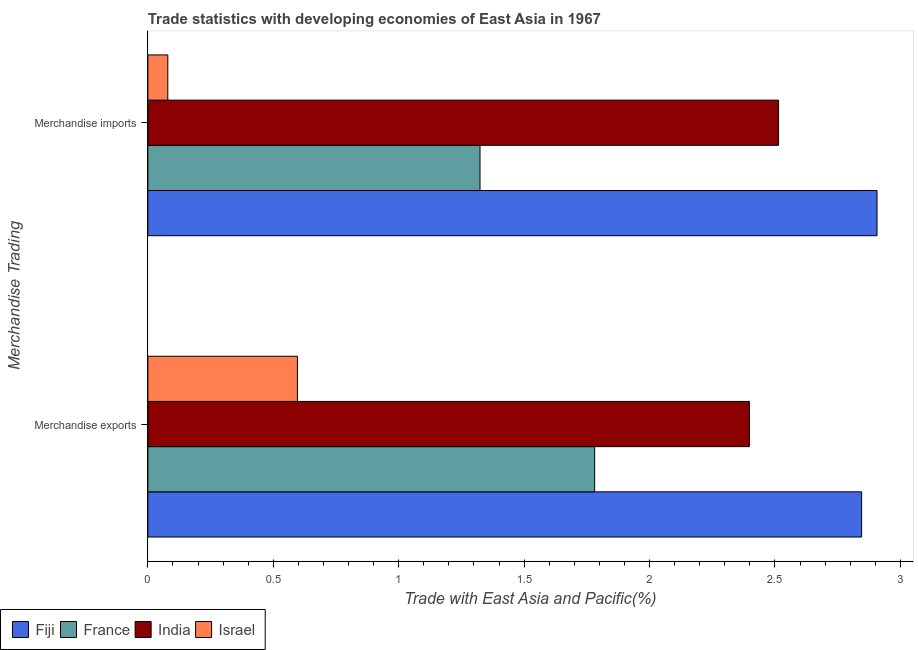How many groups of bars are there?
Make the answer very short. 2. Are the number of bars per tick equal to the number of legend labels?
Your response must be concise. Yes. Are the number of bars on each tick of the Y-axis equal?
Provide a short and direct response. Yes. How many bars are there on the 1st tick from the top?
Offer a terse response. 4. What is the label of the 2nd group of bars from the top?
Offer a very short reply. Merchandise exports. What is the merchandise exports in Israel?
Your answer should be compact. 0.6. Across all countries, what is the maximum merchandise imports?
Your response must be concise. 2.91. Across all countries, what is the minimum merchandise imports?
Your answer should be very brief. 0.08. In which country was the merchandise exports maximum?
Provide a short and direct response. Fiji. What is the total merchandise exports in the graph?
Keep it short and to the point. 7.62. What is the difference between the merchandise imports in France and that in Israel?
Offer a very short reply. 1.24. What is the difference between the merchandise exports in India and the merchandise imports in France?
Provide a short and direct response. 1.07. What is the average merchandise imports per country?
Your answer should be compact. 1.71. What is the difference between the merchandise imports and merchandise exports in India?
Your response must be concise. 0.12. In how many countries, is the merchandise imports greater than 0.4 %?
Give a very brief answer. 3. What is the ratio of the merchandise imports in Israel to that in France?
Make the answer very short. 0.06. In how many countries, is the merchandise exports greater than the average merchandise exports taken over all countries?
Ensure brevity in your answer.  2. What does the 2nd bar from the top in Merchandise imports represents?
Make the answer very short. India. What does the 2nd bar from the bottom in Merchandise exports represents?
Keep it short and to the point. France. How many bars are there?
Make the answer very short. 8. Are all the bars in the graph horizontal?
Provide a succinct answer. Yes. Does the graph contain any zero values?
Offer a terse response. No. Where does the legend appear in the graph?
Keep it short and to the point. Bottom left. How are the legend labels stacked?
Offer a terse response. Horizontal. What is the title of the graph?
Ensure brevity in your answer.  Trade statistics with developing economies of East Asia in 1967. What is the label or title of the X-axis?
Give a very brief answer. Trade with East Asia and Pacific(%). What is the label or title of the Y-axis?
Your answer should be compact. Merchandise Trading. What is the Trade with East Asia and Pacific(%) of Fiji in Merchandise exports?
Your answer should be compact. 2.85. What is the Trade with East Asia and Pacific(%) in France in Merchandise exports?
Provide a succinct answer. 1.78. What is the Trade with East Asia and Pacific(%) in India in Merchandise exports?
Provide a short and direct response. 2.4. What is the Trade with East Asia and Pacific(%) of Israel in Merchandise exports?
Offer a terse response. 0.6. What is the Trade with East Asia and Pacific(%) of Fiji in Merchandise imports?
Your answer should be compact. 2.91. What is the Trade with East Asia and Pacific(%) in France in Merchandise imports?
Your answer should be compact. 1.32. What is the Trade with East Asia and Pacific(%) in India in Merchandise imports?
Your answer should be compact. 2.51. What is the Trade with East Asia and Pacific(%) of Israel in Merchandise imports?
Your answer should be compact. 0.08. Across all Merchandise Trading, what is the maximum Trade with East Asia and Pacific(%) of Fiji?
Your answer should be compact. 2.91. Across all Merchandise Trading, what is the maximum Trade with East Asia and Pacific(%) of France?
Provide a succinct answer. 1.78. Across all Merchandise Trading, what is the maximum Trade with East Asia and Pacific(%) in India?
Offer a terse response. 2.51. Across all Merchandise Trading, what is the maximum Trade with East Asia and Pacific(%) of Israel?
Offer a terse response. 0.6. Across all Merchandise Trading, what is the minimum Trade with East Asia and Pacific(%) in Fiji?
Your answer should be very brief. 2.85. Across all Merchandise Trading, what is the minimum Trade with East Asia and Pacific(%) in France?
Your response must be concise. 1.32. Across all Merchandise Trading, what is the minimum Trade with East Asia and Pacific(%) of India?
Give a very brief answer. 2.4. Across all Merchandise Trading, what is the minimum Trade with East Asia and Pacific(%) in Israel?
Ensure brevity in your answer.  0.08. What is the total Trade with East Asia and Pacific(%) in Fiji in the graph?
Keep it short and to the point. 5.75. What is the total Trade with East Asia and Pacific(%) of France in the graph?
Give a very brief answer. 3.11. What is the total Trade with East Asia and Pacific(%) of India in the graph?
Provide a succinct answer. 4.91. What is the total Trade with East Asia and Pacific(%) in Israel in the graph?
Ensure brevity in your answer.  0.68. What is the difference between the Trade with East Asia and Pacific(%) of Fiji in Merchandise exports and that in Merchandise imports?
Make the answer very short. -0.06. What is the difference between the Trade with East Asia and Pacific(%) in France in Merchandise exports and that in Merchandise imports?
Offer a terse response. 0.46. What is the difference between the Trade with East Asia and Pacific(%) in India in Merchandise exports and that in Merchandise imports?
Provide a short and direct response. -0.12. What is the difference between the Trade with East Asia and Pacific(%) of Israel in Merchandise exports and that in Merchandise imports?
Offer a very short reply. 0.52. What is the difference between the Trade with East Asia and Pacific(%) of Fiji in Merchandise exports and the Trade with East Asia and Pacific(%) of France in Merchandise imports?
Ensure brevity in your answer.  1.52. What is the difference between the Trade with East Asia and Pacific(%) in Fiji in Merchandise exports and the Trade with East Asia and Pacific(%) in India in Merchandise imports?
Offer a very short reply. 0.33. What is the difference between the Trade with East Asia and Pacific(%) of Fiji in Merchandise exports and the Trade with East Asia and Pacific(%) of Israel in Merchandise imports?
Offer a very short reply. 2.77. What is the difference between the Trade with East Asia and Pacific(%) of France in Merchandise exports and the Trade with East Asia and Pacific(%) of India in Merchandise imports?
Offer a terse response. -0.73. What is the difference between the Trade with East Asia and Pacific(%) of France in Merchandise exports and the Trade with East Asia and Pacific(%) of Israel in Merchandise imports?
Offer a very short reply. 1.7. What is the difference between the Trade with East Asia and Pacific(%) of India in Merchandise exports and the Trade with East Asia and Pacific(%) of Israel in Merchandise imports?
Your response must be concise. 2.32. What is the average Trade with East Asia and Pacific(%) in Fiji per Merchandise Trading?
Your answer should be compact. 2.88. What is the average Trade with East Asia and Pacific(%) of France per Merchandise Trading?
Your answer should be very brief. 1.55. What is the average Trade with East Asia and Pacific(%) in India per Merchandise Trading?
Give a very brief answer. 2.46. What is the average Trade with East Asia and Pacific(%) in Israel per Merchandise Trading?
Your answer should be very brief. 0.34. What is the difference between the Trade with East Asia and Pacific(%) of Fiji and Trade with East Asia and Pacific(%) of France in Merchandise exports?
Make the answer very short. 1.06. What is the difference between the Trade with East Asia and Pacific(%) in Fiji and Trade with East Asia and Pacific(%) in India in Merchandise exports?
Your response must be concise. 0.45. What is the difference between the Trade with East Asia and Pacific(%) of Fiji and Trade with East Asia and Pacific(%) of Israel in Merchandise exports?
Make the answer very short. 2.25. What is the difference between the Trade with East Asia and Pacific(%) of France and Trade with East Asia and Pacific(%) of India in Merchandise exports?
Your answer should be very brief. -0.62. What is the difference between the Trade with East Asia and Pacific(%) in France and Trade with East Asia and Pacific(%) in Israel in Merchandise exports?
Your response must be concise. 1.18. What is the difference between the Trade with East Asia and Pacific(%) in India and Trade with East Asia and Pacific(%) in Israel in Merchandise exports?
Make the answer very short. 1.8. What is the difference between the Trade with East Asia and Pacific(%) of Fiji and Trade with East Asia and Pacific(%) of France in Merchandise imports?
Your answer should be very brief. 1.58. What is the difference between the Trade with East Asia and Pacific(%) of Fiji and Trade with East Asia and Pacific(%) of India in Merchandise imports?
Offer a terse response. 0.39. What is the difference between the Trade with East Asia and Pacific(%) of Fiji and Trade with East Asia and Pacific(%) of Israel in Merchandise imports?
Offer a very short reply. 2.83. What is the difference between the Trade with East Asia and Pacific(%) of France and Trade with East Asia and Pacific(%) of India in Merchandise imports?
Provide a succinct answer. -1.19. What is the difference between the Trade with East Asia and Pacific(%) in France and Trade with East Asia and Pacific(%) in Israel in Merchandise imports?
Give a very brief answer. 1.24. What is the difference between the Trade with East Asia and Pacific(%) of India and Trade with East Asia and Pacific(%) of Israel in Merchandise imports?
Ensure brevity in your answer.  2.43. What is the ratio of the Trade with East Asia and Pacific(%) of Fiji in Merchandise exports to that in Merchandise imports?
Your response must be concise. 0.98. What is the ratio of the Trade with East Asia and Pacific(%) in France in Merchandise exports to that in Merchandise imports?
Provide a succinct answer. 1.35. What is the ratio of the Trade with East Asia and Pacific(%) of India in Merchandise exports to that in Merchandise imports?
Give a very brief answer. 0.95. What is the ratio of the Trade with East Asia and Pacific(%) of Israel in Merchandise exports to that in Merchandise imports?
Your response must be concise. 7.5. What is the difference between the highest and the second highest Trade with East Asia and Pacific(%) of Fiji?
Provide a succinct answer. 0.06. What is the difference between the highest and the second highest Trade with East Asia and Pacific(%) of France?
Provide a succinct answer. 0.46. What is the difference between the highest and the second highest Trade with East Asia and Pacific(%) in India?
Provide a succinct answer. 0.12. What is the difference between the highest and the second highest Trade with East Asia and Pacific(%) in Israel?
Ensure brevity in your answer.  0.52. What is the difference between the highest and the lowest Trade with East Asia and Pacific(%) in Fiji?
Make the answer very short. 0.06. What is the difference between the highest and the lowest Trade with East Asia and Pacific(%) of France?
Your answer should be very brief. 0.46. What is the difference between the highest and the lowest Trade with East Asia and Pacific(%) of India?
Make the answer very short. 0.12. What is the difference between the highest and the lowest Trade with East Asia and Pacific(%) in Israel?
Keep it short and to the point. 0.52. 